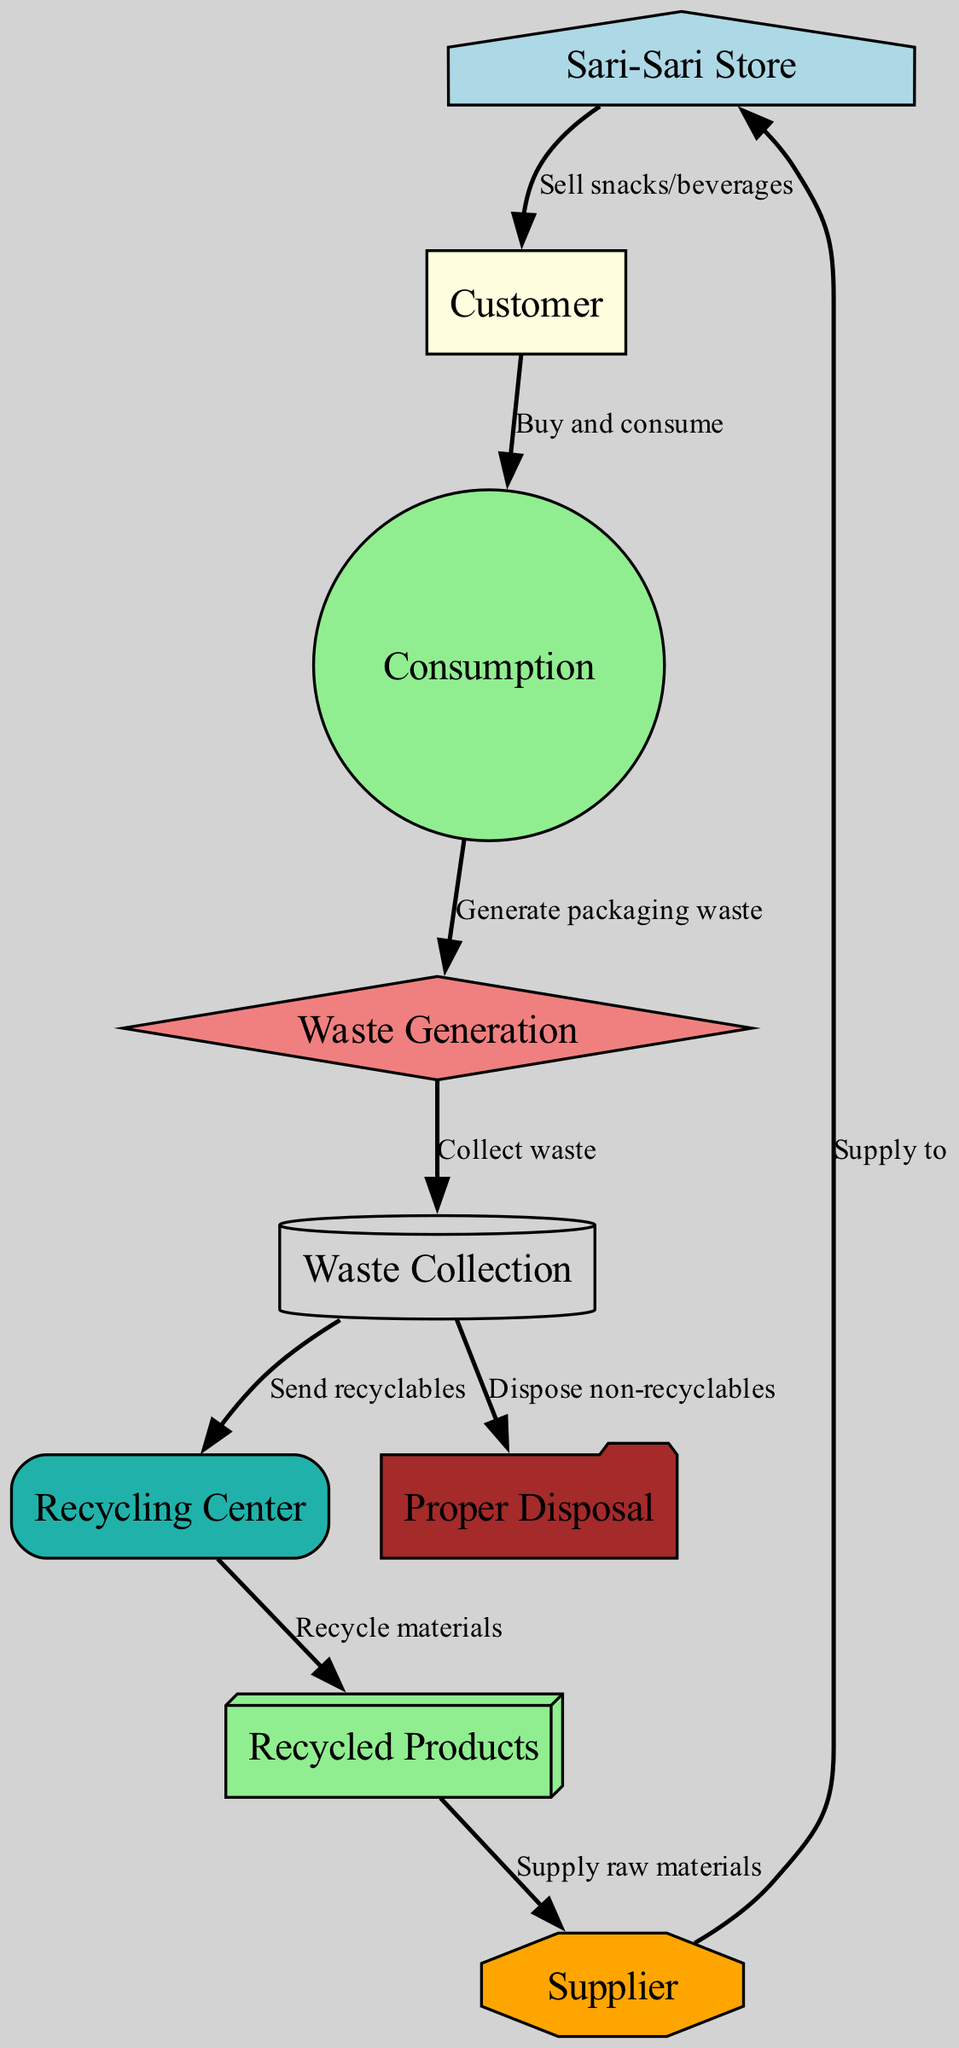What is the starting point of the waste management chain? The diagram begins at the "Sari-Sari Store," which is the source of all subsequent activities in the waste management process.
Answer: Sari-Sari Store How many nodes are in the diagram? By counting the listed nodes in the data, there are a total of 9 nodes depicting different elements of the waste management process.
Answer: 9 What follows "Waste Generation" in the flow? According to the edges in the diagram, "Waste Generation" leads directly to "Waste Collection," indicating the next step in the process after waste has been generated.
Answer: Waste Collection Which node collects waste? The "Waste Collection" node is responsible for the collection of waste generated after consumption, as indicated in the flow of the diagram.
Answer: Waste Collection What type of materials does the "Recycling Center" provide after processing? After the recycling process, the "Recycling Center" outputs "Recycled Products" as new materials that can be supplied back to suppliers.
Answer: Recycled Products How are non-recyclables managed after waste collection? Non-recyclable materials are directed towards "Proper Disposal," which is the method employed to handle waste that cannot be recycled in this diagram.
Answer: Proper Disposal What is the relationship between the "Recycled Products" and the "Supplier"? The diagram indicates a direct relationship where "Recycled Products" are supplied back to the "Supplier," showing the contribution of recycled materials to the supply chain.
Answer: Supply raw materials How does the waste reach the "Recycling Center"? Waste is sent to the "Recycling Center" after the process of waste collection, according to the directed edge in the diagram that connects these two nodes.
Answer: Send recyclables Which role does the "Customer" play in the waste management process? The "Customer" is involved in "Consumption," where they buy and consume the products, thus generating packaging waste that leads to the waste management process.
Answer: Buy and consume 